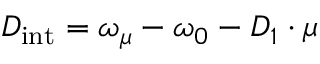Convert formula to latex. <formula><loc_0><loc_0><loc_500><loc_500>D _ { i n t } = \omega _ { \mu } - \omega _ { 0 } - D _ { 1 } \cdot \mu</formula> 